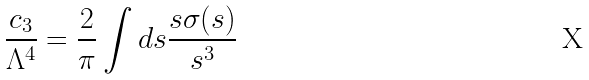Convert formula to latex. <formula><loc_0><loc_0><loc_500><loc_500>\frac { c _ { 3 } } { \Lambda ^ { 4 } } = \frac { 2 } { \pi } \int d s \frac { s \sigma ( s ) } { s ^ { 3 } }</formula> 